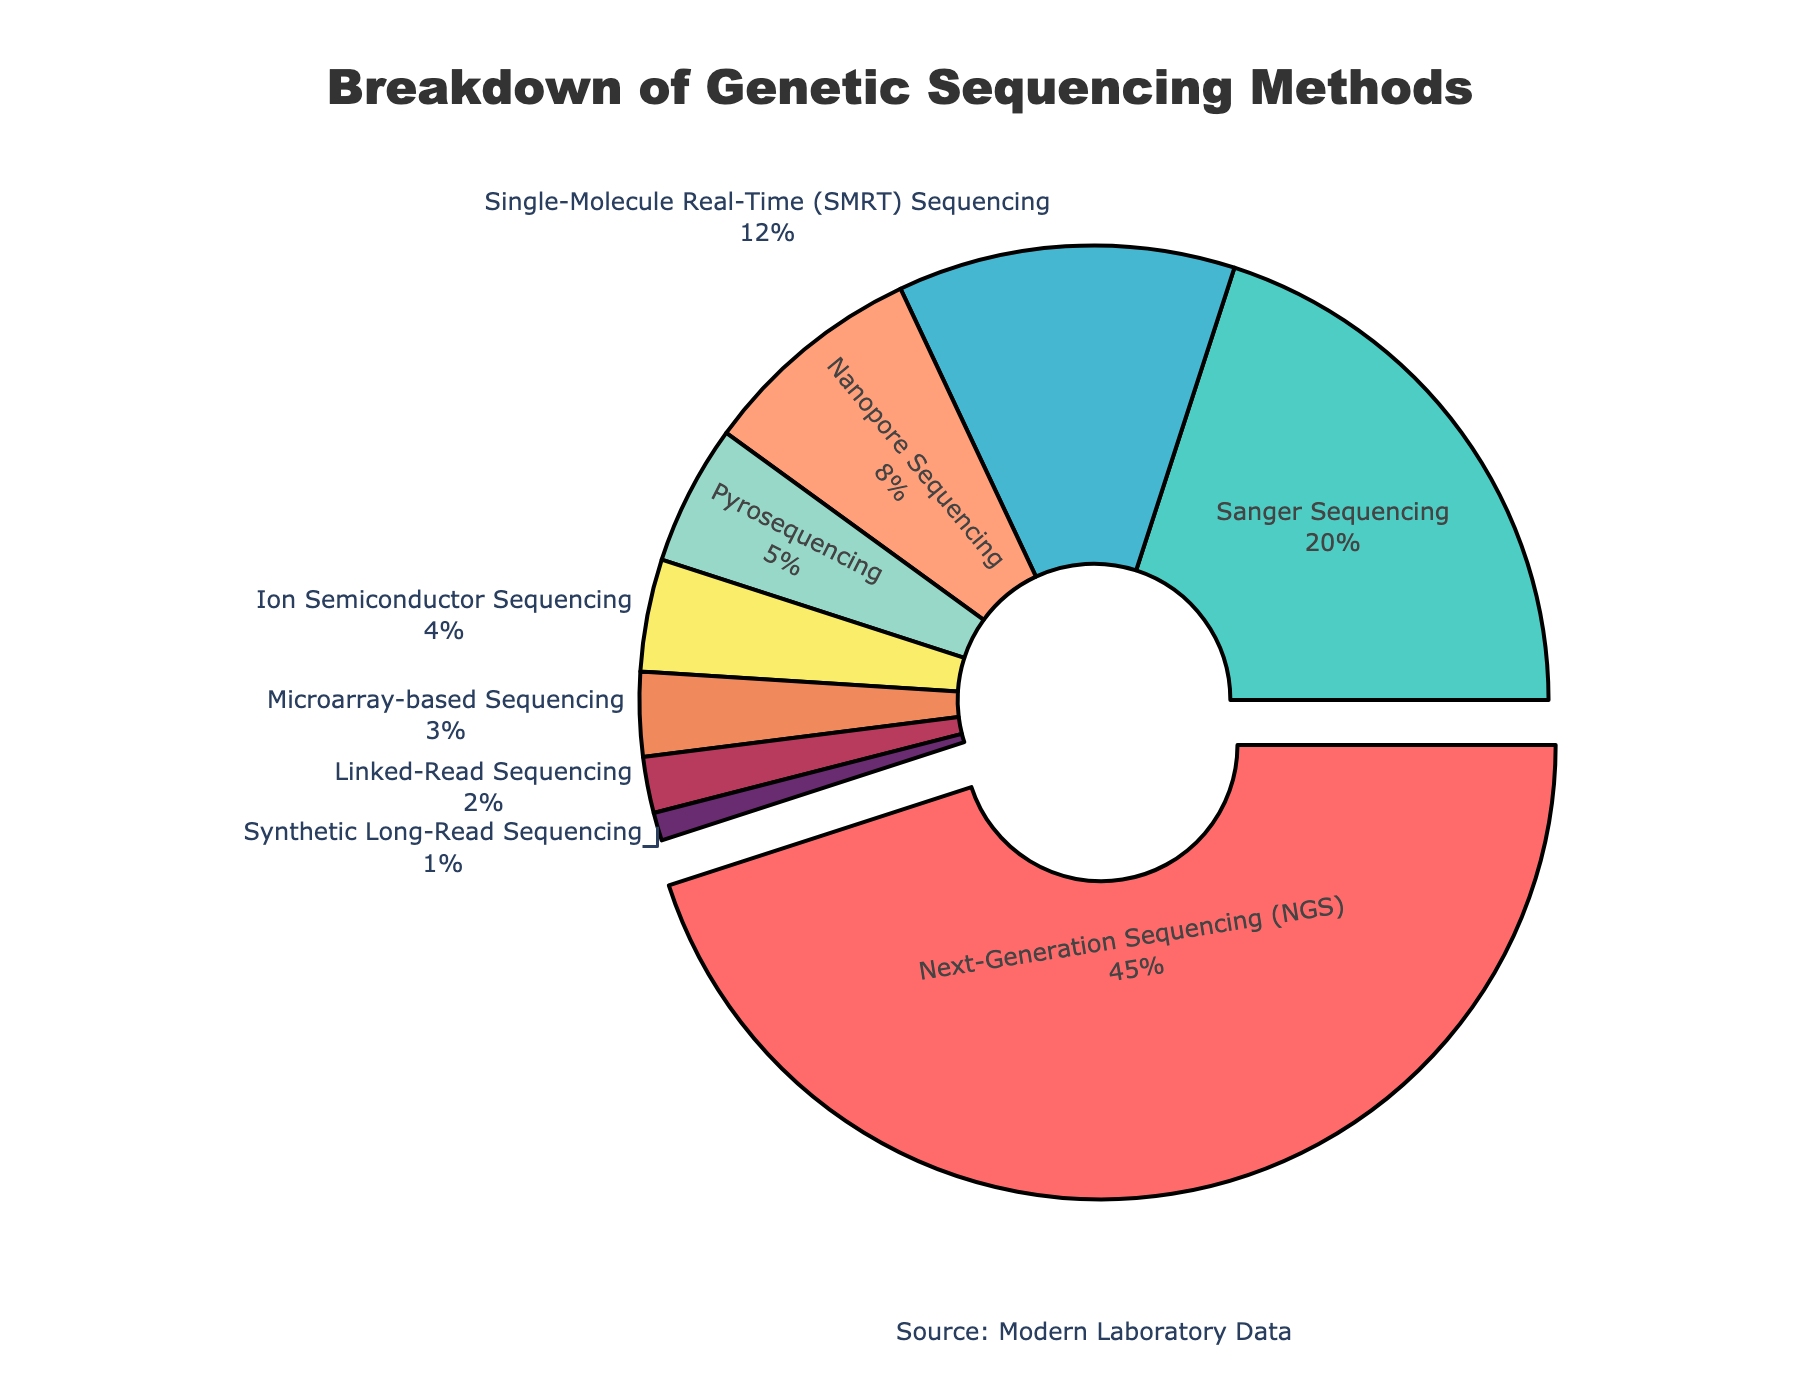Which sequencing method has the highest usage percentage? Why is it highlighted? The pie chart shows that Next-Generation Sequencing (NGS) has the largest section, indicating the highest usage percentage at 45%. It is highlighted by being slightly pulled out from the center.
Answer: Next-Generation Sequencing (NGS) What is the combined percentage of Sanger Sequencing and Nanopore Sequencing? Sanger Sequencing has a percentage of 20% and Nanopore Sequencing has 8%. Adding them together gives 20% + 8% = 28%.
Answer: 28% Which sequencing method is least used according to the pie chart? From the pie chart, Synthetic Long-Read Sequencing has the smallest portion, indicating a percentage of 1%.
Answer: Synthetic Long-Read Sequencing How does the usage of SMRT Sequencing compare to Ion Semiconductor Sequencing? The pie chart indicates that Single-Molecule Real-Time (SMRT) Sequencing has a percentage of 12%, whereas Ion Semiconductor Sequencing has 4%. Therefore, SMRT Sequencing is more widely used than Ion Semiconductor Sequencing.
Answer: SMRT Sequencing is more widely used What percentage of the total does Microarray-based Sequencing and Linked-Read Sequencing together form? Microarray-based Sequencing is 3% and Linked-Read Sequencing is 2%. Summing these together gives 3% + 2% = 5%.
Answer: 5% Which two methods combined account for the same percentage as the Nanopore Sequencing method? By examining the chart, Nanopore Sequencing is 8%. The combination of Pyrosequencing (5%) and Ion Semiconductor Sequencing (4%) results in 5% + 4% = 9%, which is approximate but not exact. However, no two methods add up exactly to 8%. Therefore, the closest combination would be the ones adding up to the closest percentage.
Answer: Pyrosequencing and Ion Semiconductor Sequencing What is the relative difference in usage percentage between Next-Generation Sequencing (NGS) and Pyrosequencing? Next-Generation Sequencing (NGS) has a usage percentage of 45% while Pyrosequencing has 5%. The difference is 45% - 5% = 40%.
Answer: 40% What is the proportion of sequencing methods that have a usage percentage less than 10%? The methods with a percentage less than 10% are Nanopore Sequencing (8%), Pyrosequencing (5%), Ion Semiconductor Sequencing (4%), Microarray-based Sequencing (3%), Linked-Read Sequencing (2%), and Synthetic Long-Read Sequencing (1%). There are 6 such methods. Out of the total 9 methods shown, the proportion is 6/9.
Answer: 6 out of 9 methods How does the combined usage percentage of the top three methods compare to the rest? The top three methods are Next-Generation Sequencing (NGS) at 45%, Sanger Sequencing at 20%, and SMRT Sequencing at 12%. Combined, they account for 45% + 20% + 12% = 77%. The remaining percentages are 8% + 5% + 4% + 3% + 2% + 1% = 23%. Therefore, the top three methods together cover much more (77%) of the total usage compared to the remaining methods (23%).
Answer: Top three account for 77%, the rest 23% 